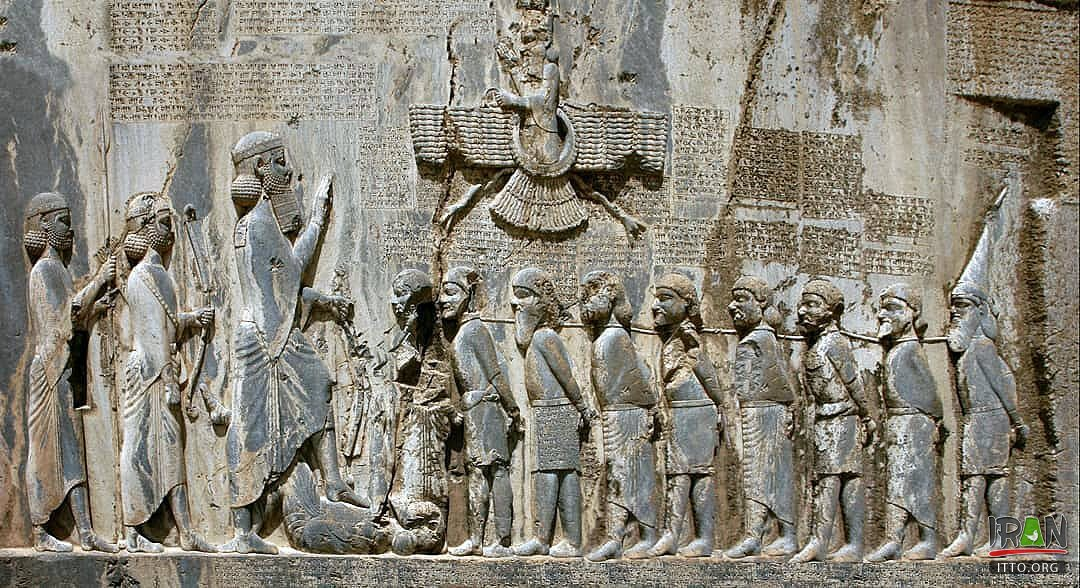What does the text around the figures represent? The text around the figures in the Behistun Inscription is incredibly significant, as it serves as a royal proclamation from Darius the Great. The inscription details his lineage and his rise to power after overthrowing the usurper Gaumata. It also lists the various rebellions he faced early in his reign and describes his subsequent victories. This text is etched in three different languages—Old Persian, Elamite, and Babylonian, which was intended to make the message accessible to a diverse empire. These writings are among the earliest known examples of each script and are crucial for the study of these languages and the history of the Persian Empire. 